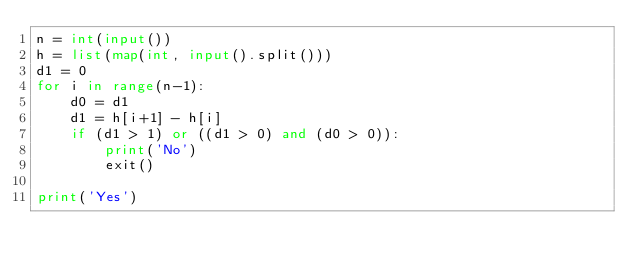<code> <loc_0><loc_0><loc_500><loc_500><_Python_>n = int(input())
h = list(map(int, input().split()))
d1 = 0
for i in range(n-1):
    d0 = d1
    d1 = h[i+1] - h[i]
    if (d1 > 1) or ((d1 > 0) and (d0 > 0)):
        print('No')
        exit()

print('Yes')</code> 